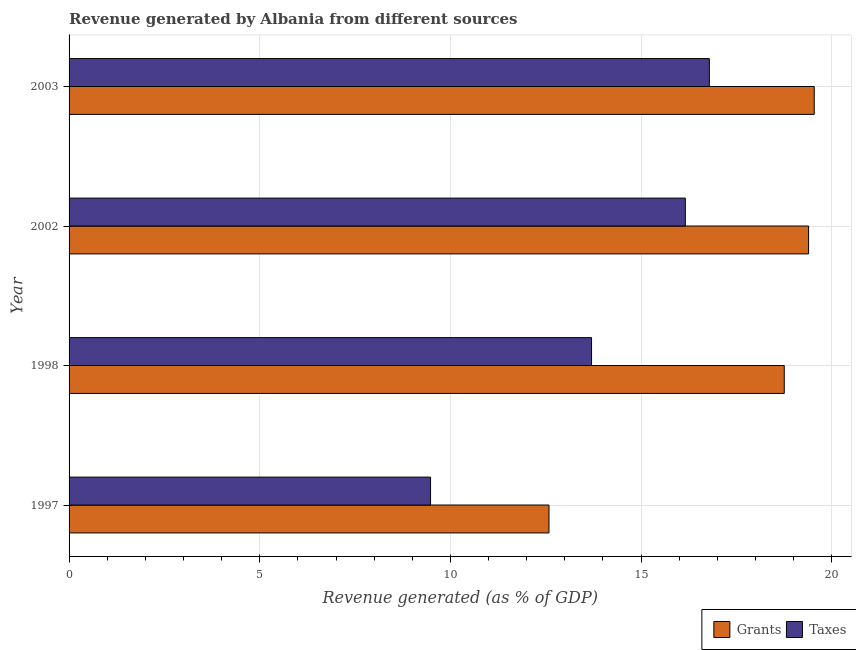How many different coloured bars are there?
Offer a terse response. 2. Are the number of bars per tick equal to the number of legend labels?
Make the answer very short. Yes. What is the label of the 1st group of bars from the top?
Offer a terse response. 2003. In how many cases, is the number of bars for a given year not equal to the number of legend labels?
Make the answer very short. 0. What is the revenue generated by taxes in 2003?
Your response must be concise. 16.79. Across all years, what is the maximum revenue generated by grants?
Make the answer very short. 19.54. Across all years, what is the minimum revenue generated by taxes?
Your response must be concise. 9.48. In which year was the revenue generated by grants maximum?
Make the answer very short. 2003. In which year was the revenue generated by taxes minimum?
Your answer should be compact. 1997. What is the total revenue generated by grants in the graph?
Give a very brief answer. 70.28. What is the difference between the revenue generated by taxes in 1997 and that in 2002?
Give a very brief answer. -6.68. What is the difference between the revenue generated by grants in 1997 and the revenue generated by taxes in 2003?
Your response must be concise. -4.21. What is the average revenue generated by grants per year?
Ensure brevity in your answer.  17.57. In the year 2003, what is the difference between the revenue generated by grants and revenue generated by taxes?
Make the answer very short. 2.75. What is the ratio of the revenue generated by grants in 1997 to that in 2003?
Keep it short and to the point. 0.64. Is the revenue generated by taxes in 1997 less than that in 2002?
Your answer should be compact. Yes. What is the difference between the highest and the second highest revenue generated by grants?
Make the answer very short. 0.15. What is the difference between the highest and the lowest revenue generated by grants?
Your answer should be compact. 6.96. What does the 2nd bar from the top in 1997 represents?
Provide a short and direct response. Grants. What does the 1st bar from the bottom in 1997 represents?
Offer a very short reply. Grants. What is the difference between two consecutive major ticks on the X-axis?
Ensure brevity in your answer.  5. Are the values on the major ticks of X-axis written in scientific E-notation?
Provide a short and direct response. No. Does the graph contain any zero values?
Your answer should be very brief. No. Does the graph contain grids?
Offer a very short reply. Yes. How are the legend labels stacked?
Your response must be concise. Horizontal. What is the title of the graph?
Provide a succinct answer. Revenue generated by Albania from different sources. What is the label or title of the X-axis?
Keep it short and to the point. Revenue generated (as % of GDP). What is the Revenue generated (as % of GDP) of Grants in 1997?
Your answer should be compact. 12.59. What is the Revenue generated (as % of GDP) in Taxes in 1997?
Your answer should be very brief. 9.48. What is the Revenue generated (as % of GDP) of Grants in 1998?
Offer a very short reply. 18.76. What is the Revenue generated (as % of GDP) in Taxes in 1998?
Your answer should be compact. 13.7. What is the Revenue generated (as % of GDP) of Grants in 2002?
Your answer should be compact. 19.39. What is the Revenue generated (as % of GDP) of Taxes in 2002?
Your answer should be very brief. 16.16. What is the Revenue generated (as % of GDP) of Grants in 2003?
Make the answer very short. 19.54. What is the Revenue generated (as % of GDP) of Taxes in 2003?
Ensure brevity in your answer.  16.79. Across all years, what is the maximum Revenue generated (as % of GDP) of Grants?
Make the answer very short. 19.54. Across all years, what is the maximum Revenue generated (as % of GDP) of Taxes?
Offer a terse response. 16.79. Across all years, what is the minimum Revenue generated (as % of GDP) of Grants?
Your answer should be very brief. 12.59. Across all years, what is the minimum Revenue generated (as % of GDP) of Taxes?
Offer a terse response. 9.48. What is the total Revenue generated (as % of GDP) in Grants in the graph?
Your response must be concise. 70.28. What is the total Revenue generated (as % of GDP) in Taxes in the graph?
Offer a terse response. 56.13. What is the difference between the Revenue generated (as % of GDP) of Grants in 1997 and that in 1998?
Give a very brief answer. -6.17. What is the difference between the Revenue generated (as % of GDP) in Taxes in 1997 and that in 1998?
Give a very brief answer. -4.22. What is the difference between the Revenue generated (as % of GDP) of Grants in 1997 and that in 2002?
Make the answer very short. -6.81. What is the difference between the Revenue generated (as % of GDP) of Taxes in 1997 and that in 2002?
Ensure brevity in your answer.  -6.68. What is the difference between the Revenue generated (as % of GDP) of Grants in 1997 and that in 2003?
Make the answer very short. -6.96. What is the difference between the Revenue generated (as % of GDP) in Taxes in 1997 and that in 2003?
Your answer should be very brief. -7.31. What is the difference between the Revenue generated (as % of GDP) of Grants in 1998 and that in 2002?
Provide a short and direct response. -0.64. What is the difference between the Revenue generated (as % of GDP) of Taxes in 1998 and that in 2002?
Make the answer very short. -2.46. What is the difference between the Revenue generated (as % of GDP) in Grants in 1998 and that in 2003?
Your response must be concise. -0.79. What is the difference between the Revenue generated (as % of GDP) in Taxes in 1998 and that in 2003?
Your response must be concise. -3.09. What is the difference between the Revenue generated (as % of GDP) of Grants in 2002 and that in 2003?
Give a very brief answer. -0.15. What is the difference between the Revenue generated (as % of GDP) of Taxes in 2002 and that in 2003?
Provide a succinct answer. -0.63. What is the difference between the Revenue generated (as % of GDP) in Grants in 1997 and the Revenue generated (as % of GDP) in Taxes in 1998?
Keep it short and to the point. -1.12. What is the difference between the Revenue generated (as % of GDP) in Grants in 1997 and the Revenue generated (as % of GDP) in Taxes in 2002?
Provide a succinct answer. -3.58. What is the difference between the Revenue generated (as % of GDP) of Grants in 1997 and the Revenue generated (as % of GDP) of Taxes in 2003?
Provide a succinct answer. -4.21. What is the difference between the Revenue generated (as % of GDP) of Grants in 1998 and the Revenue generated (as % of GDP) of Taxes in 2002?
Your answer should be compact. 2.59. What is the difference between the Revenue generated (as % of GDP) of Grants in 1998 and the Revenue generated (as % of GDP) of Taxes in 2003?
Your answer should be compact. 1.96. What is the difference between the Revenue generated (as % of GDP) of Grants in 2002 and the Revenue generated (as % of GDP) of Taxes in 2003?
Give a very brief answer. 2.6. What is the average Revenue generated (as % of GDP) of Grants per year?
Provide a short and direct response. 17.57. What is the average Revenue generated (as % of GDP) in Taxes per year?
Your answer should be compact. 14.03. In the year 1997, what is the difference between the Revenue generated (as % of GDP) in Grants and Revenue generated (as % of GDP) in Taxes?
Keep it short and to the point. 3.11. In the year 1998, what is the difference between the Revenue generated (as % of GDP) in Grants and Revenue generated (as % of GDP) in Taxes?
Offer a very short reply. 5.05. In the year 2002, what is the difference between the Revenue generated (as % of GDP) of Grants and Revenue generated (as % of GDP) of Taxes?
Make the answer very short. 3.23. In the year 2003, what is the difference between the Revenue generated (as % of GDP) in Grants and Revenue generated (as % of GDP) in Taxes?
Your answer should be compact. 2.75. What is the ratio of the Revenue generated (as % of GDP) of Grants in 1997 to that in 1998?
Your response must be concise. 0.67. What is the ratio of the Revenue generated (as % of GDP) in Taxes in 1997 to that in 1998?
Keep it short and to the point. 0.69. What is the ratio of the Revenue generated (as % of GDP) in Grants in 1997 to that in 2002?
Your response must be concise. 0.65. What is the ratio of the Revenue generated (as % of GDP) in Taxes in 1997 to that in 2002?
Give a very brief answer. 0.59. What is the ratio of the Revenue generated (as % of GDP) of Grants in 1997 to that in 2003?
Give a very brief answer. 0.64. What is the ratio of the Revenue generated (as % of GDP) in Taxes in 1997 to that in 2003?
Offer a terse response. 0.56. What is the ratio of the Revenue generated (as % of GDP) in Grants in 1998 to that in 2002?
Keep it short and to the point. 0.97. What is the ratio of the Revenue generated (as % of GDP) of Taxes in 1998 to that in 2002?
Keep it short and to the point. 0.85. What is the ratio of the Revenue generated (as % of GDP) in Grants in 1998 to that in 2003?
Provide a succinct answer. 0.96. What is the ratio of the Revenue generated (as % of GDP) of Taxes in 1998 to that in 2003?
Your answer should be very brief. 0.82. What is the ratio of the Revenue generated (as % of GDP) in Taxes in 2002 to that in 2003?
Offer a terse response. 0.96. What is the difference between the highest and the second highest Revenue generated (as % of GDP) in Grants?
Offer a terse response. 0.15. What is the difference between the highest and the second highest Revenue generated (as % of GDP) in Taxes?
Make the answer very short. 0.63. What is the difference between the highest and the lowest Revenue generated (as % of GDP) of Grants?
Provide a short and direct response. 6.96. What is the difference between the highest and the lowest Revenue generated (as % of GDP) in Taxes?
Your answer should be very brief. 7.31. 